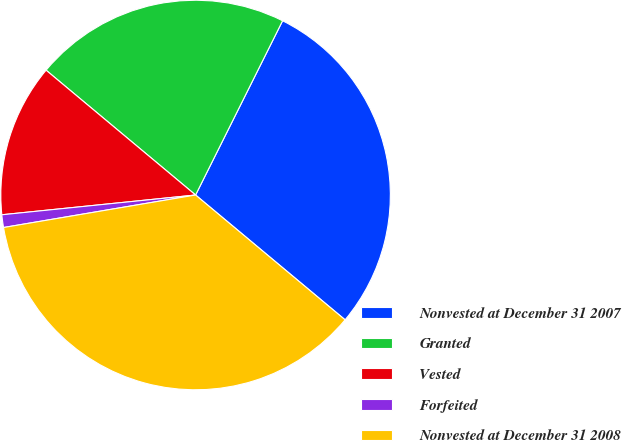Convert chart. <chart><loc_0><loc_0><loc_500><loc_500><pie_chart><fcel>Nonvested at December 31 2007<fcel>Granted<fcel>Vested<fcel>Forfeited<fcel>Nonvested at December 31 2008<nl><fcel>28.7%<fcel>21.3%<fcel>12.69%<fcel>1.05%<fcel>36.26%<nl></chart> 